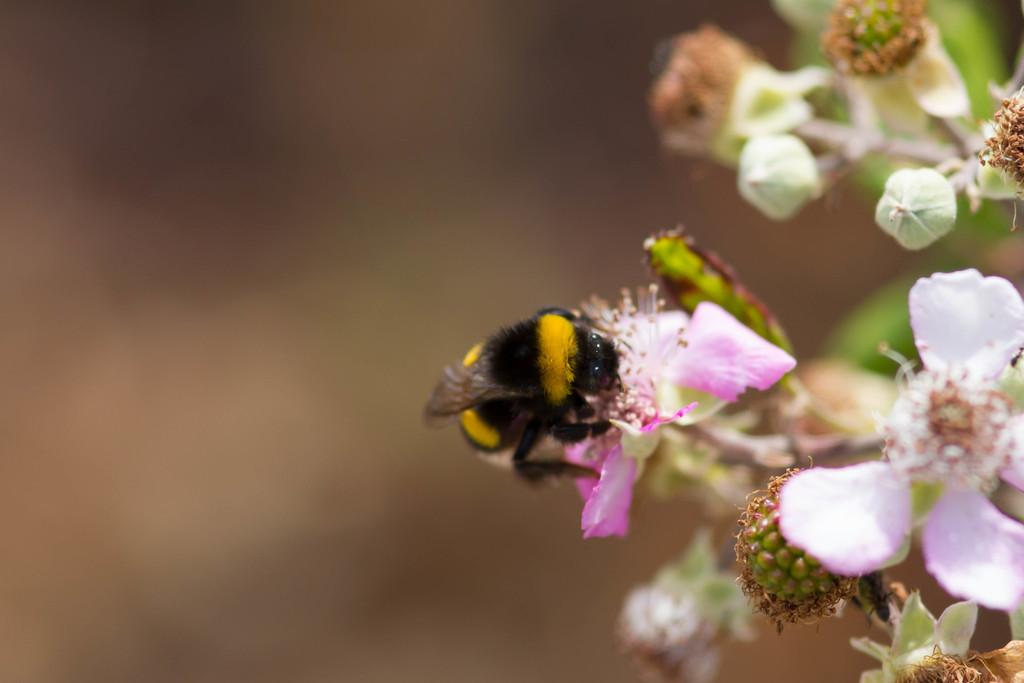What type of living organism can be seen in the image? There is an insect in the image. What type of plants are visible in the image? There are flowers, buds, and leaves in the image. How would you describe the background of the image? The background of the image is blurry. What type of office furniture can be seen in the image? There is no office furniture present in the image; it features an insect and various plant elements. Who is the secretary in the image? There is no secretary present in the image. 